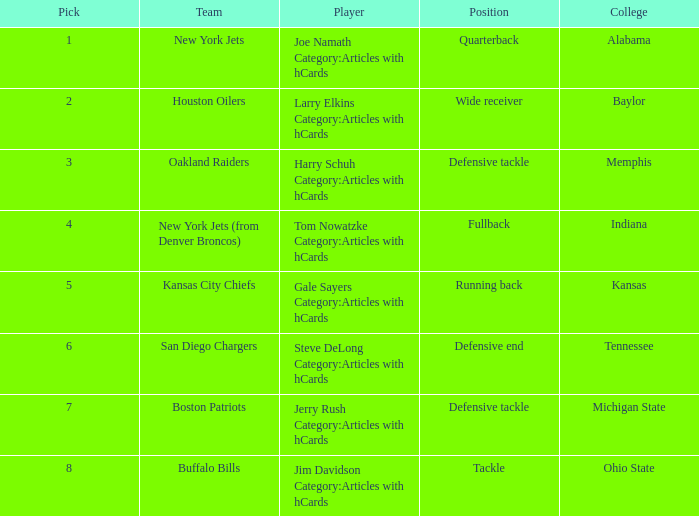Which player is from Ohio State College? Jim Davidson Category:Articles with hCards. 